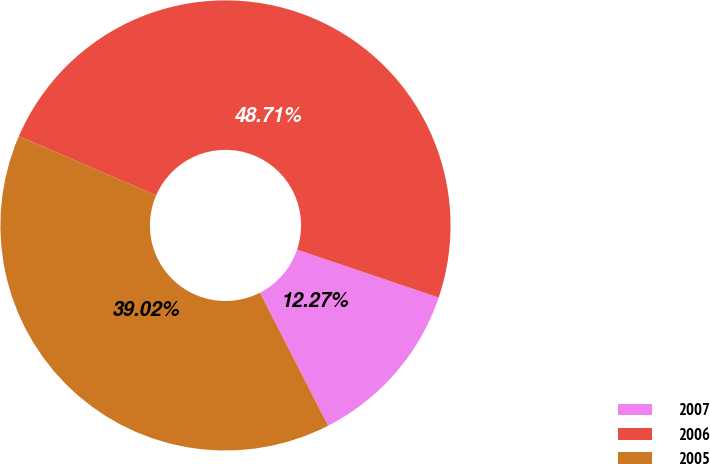Convert chart to OTSL. <chart><loc_0><loc_0><loc_500><loc_500><pie_chart><fcel>2007<fcel>2006<fcel>2005<nl><fcel>12.27%<fcel>48.71%<fcel>39.02%<nl></chart> 